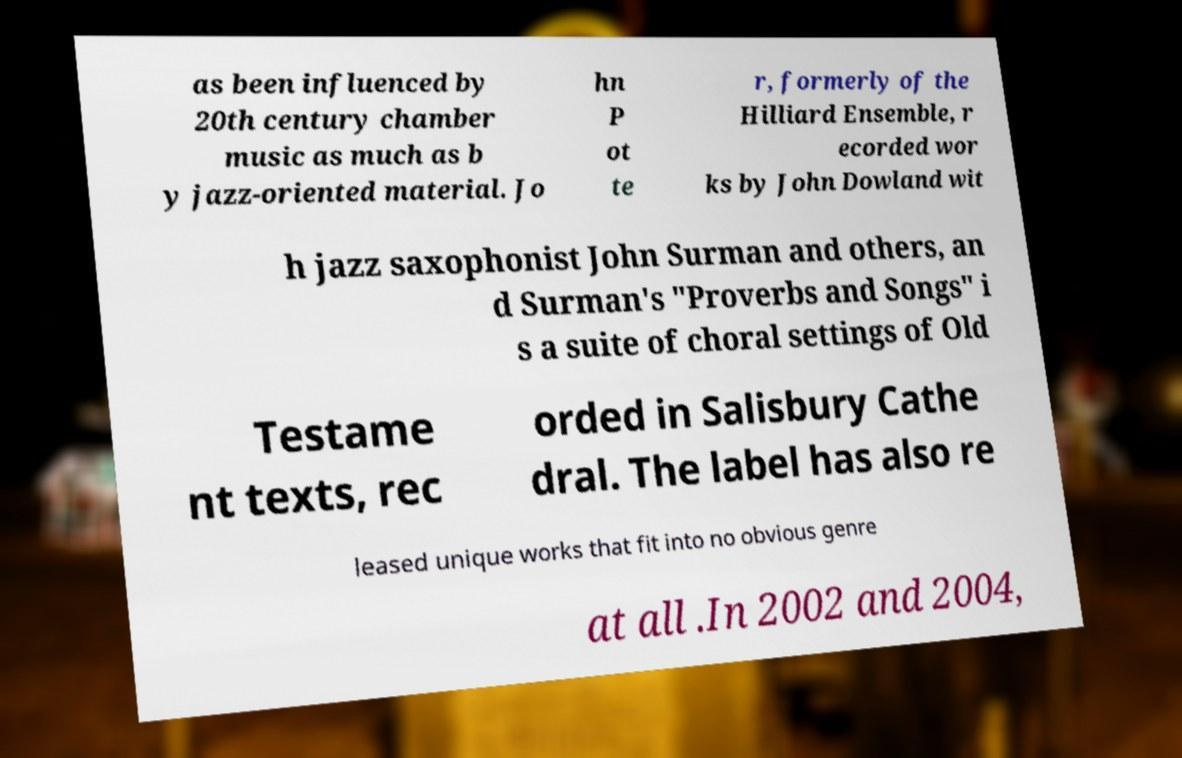Could you extract and type out the text from this image? as been influenced by 20th century chamber music as much as b y jazz-oriented material. Jo hn P ot te r, formerly of the Hilliard Ensemble, r ecorded wor ks by John Dowland wit h jazz saxophonist John Surman and others, an d Surman's "Proverbs and Songs" i s a suite of choral settings of Old Testame nt texts, rec orded in Salisbury Cathe dral. The label has also re leased unique works that fit into no obvious genre at all .In 2002 and 2004, 